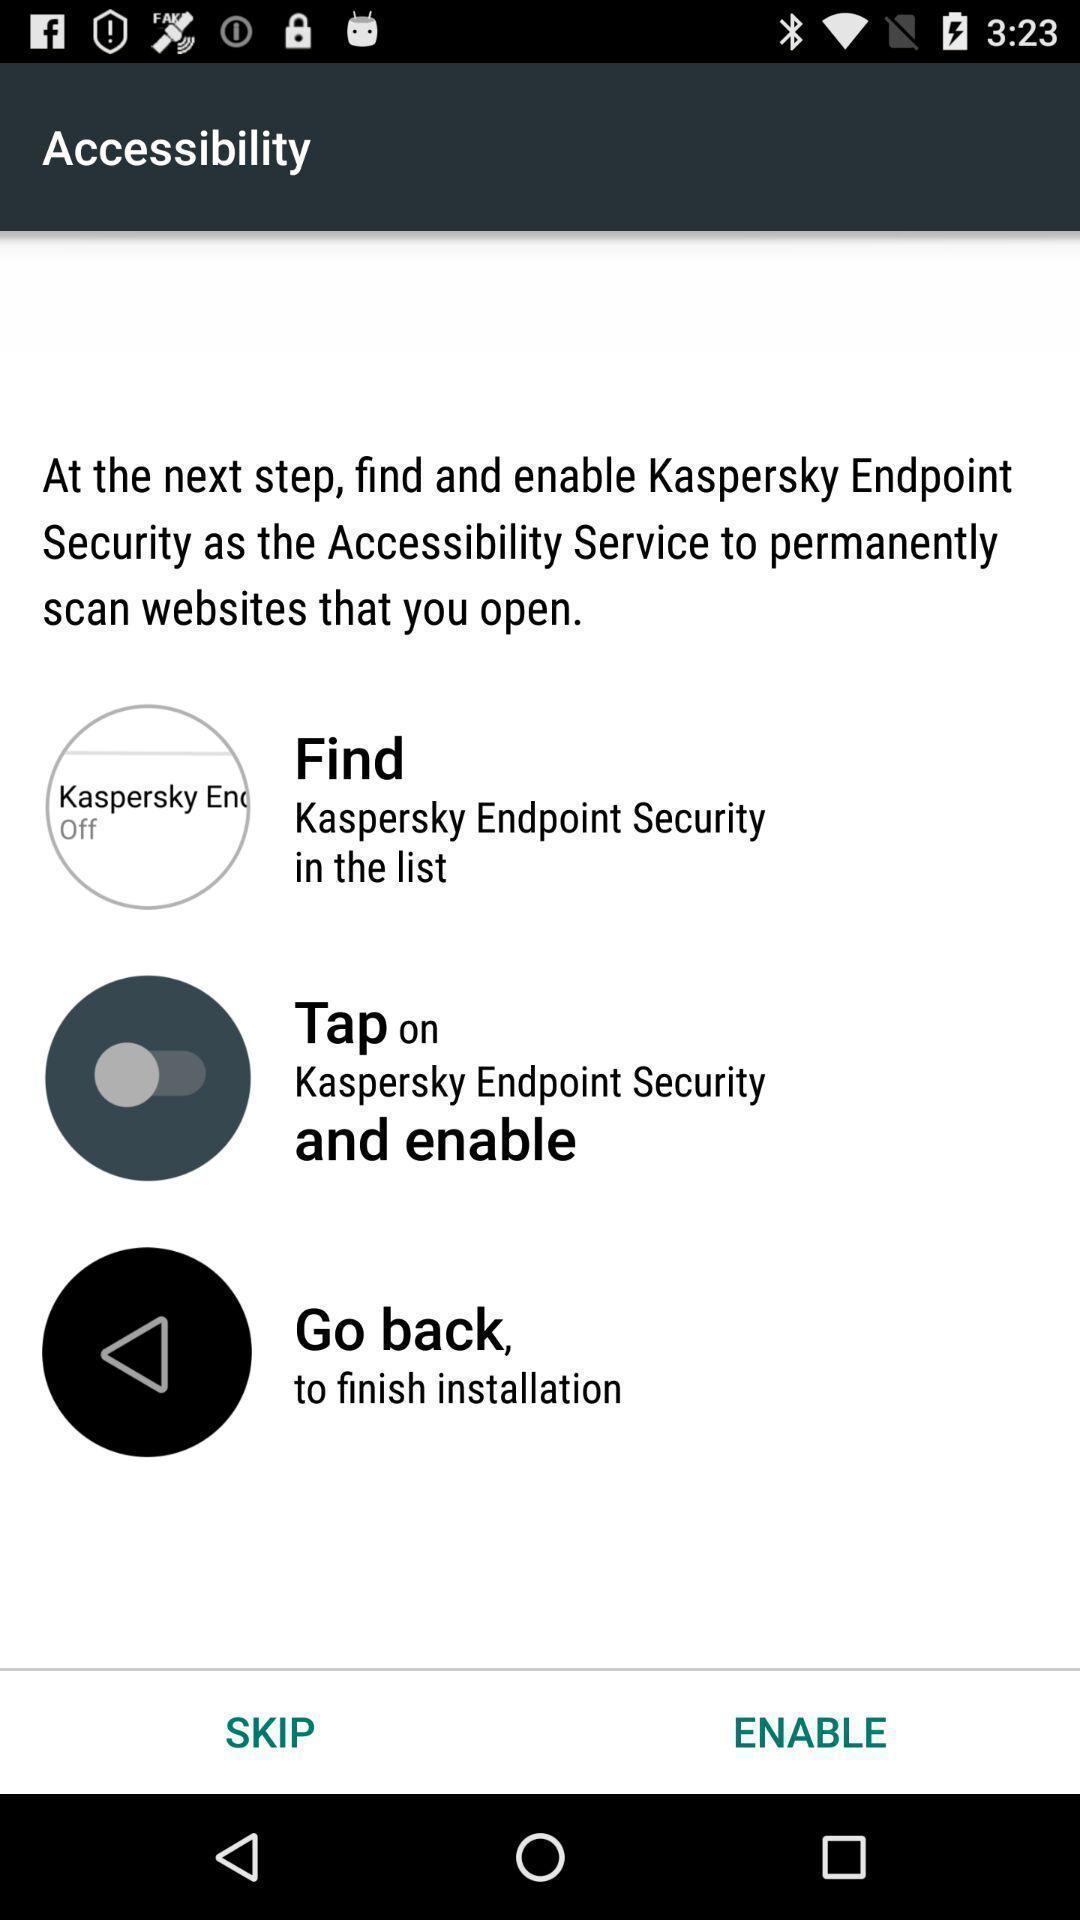Give me a narrative description of this picture. Page with different options in the device security app. 